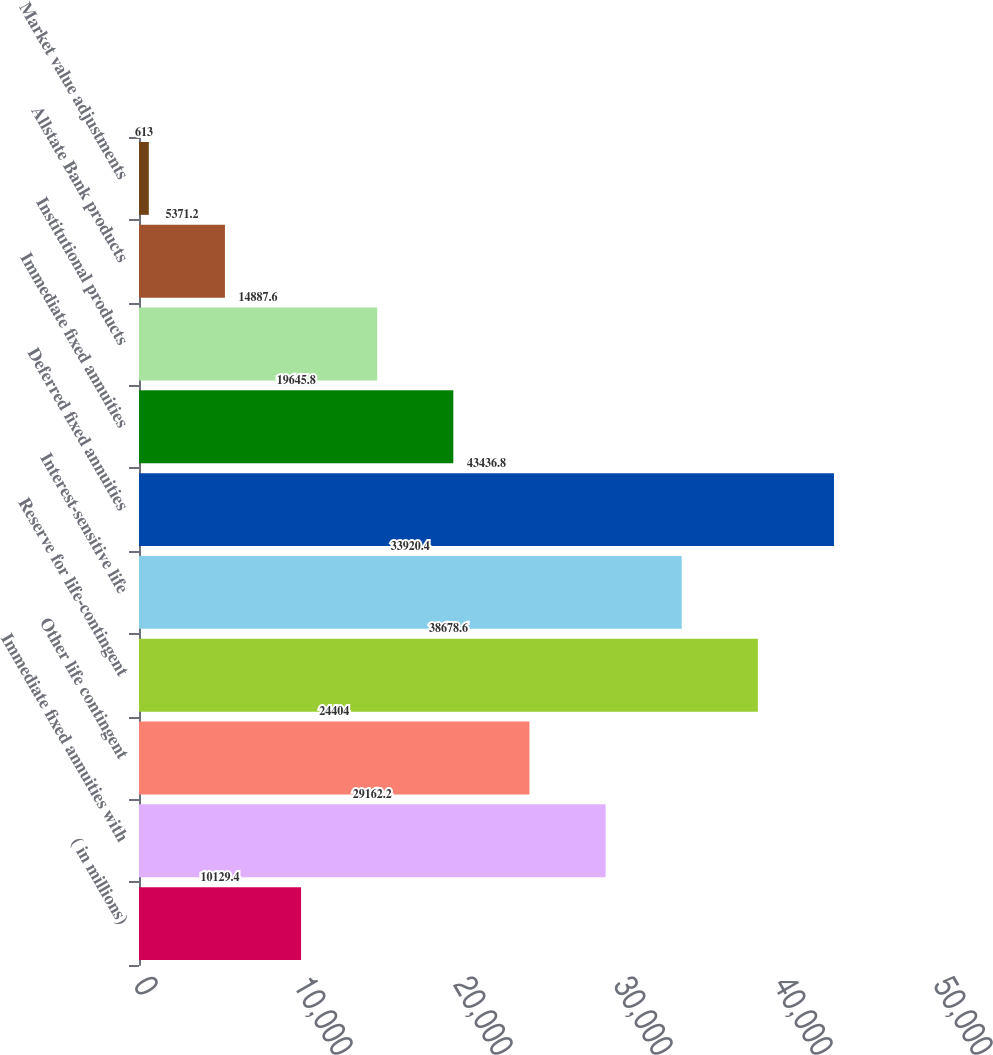Convert chart. <chart><loc_0><loc_0><loc_500><loc_500><bar_chart><fcel>( in millions)<fcel>Immediate fixed annuities with<fcel>Other life contingent<fcel>Reserve for life-contingent<fcel>Interest-sensitive life<fcel>Deferred fixed annuities<fcel>Immediate fixed annuities<fcel>Institutional products<fcel>Allstate Bank products<fcel>Market value adjustments<nl><fcel>10129.4<fcel>29162.2<fcel>24404<fcel>38678.6<fcel>33920.4<fcel>43436.8<fcel>19645.8<fcel>14887.6<fcel>5371.2<fcel>613<nl></chart> 